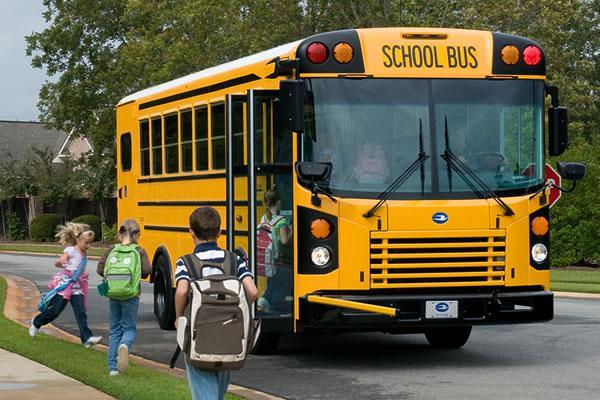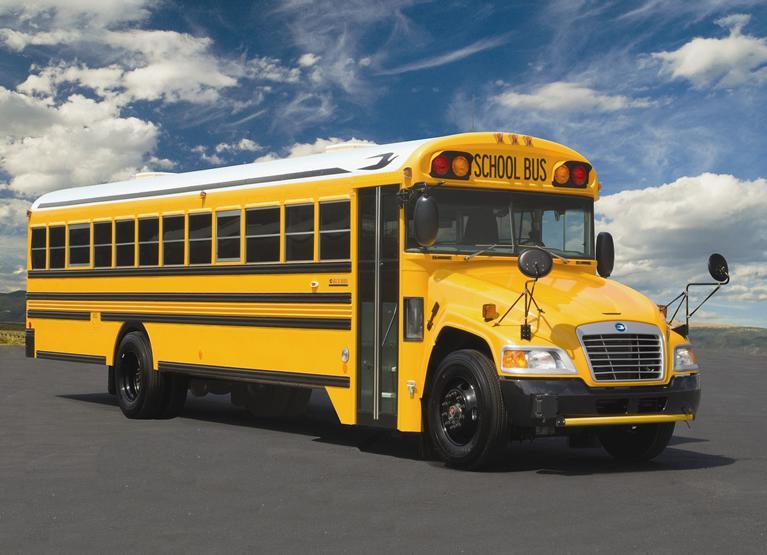The first image is the image on the left, the second image is the image on the right. Considering the images on both sides, is "The left and right image contains the same number of buses that are facing somewhat forward." valid? Answer yes or no. Yes. The first image is the image on the left, the second image is the image on the right. Analyze the images presented: Is the assertion "Each image shows a bus with a non-flat front that is facing toward the camera." valid? Answer yes or no. No. 